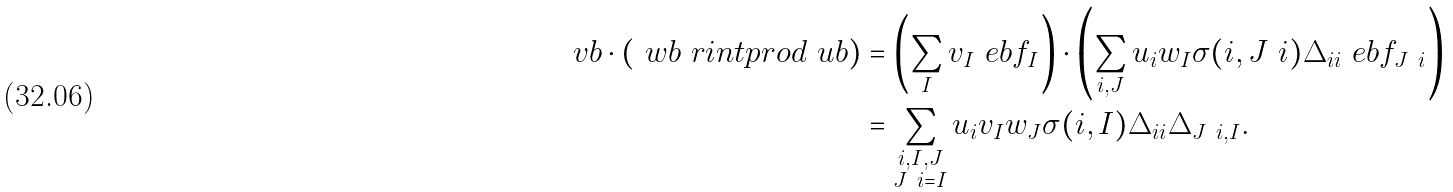Convert formula to latex. <formula><loc_0><loc_0><loc_500><loc_500>\ v b \cdot ( \ w b \ r i n t p r o d \ u b ) & = \left ( \sum _ { I } v _ { I } \ e b f _ { I } \right ) \cdot \left ( \sum _ { i , J } u _ { i } w _ { I } \sigma ( i , J \ i ) \Delta _ { i i } \ e b f _ { J \ i } \right ) \\ & = \sum _ { \substack { i , I , J \\ J \ i = I } } u _ { i } v _ { I } w _ { J } \sigma ( i , I ) \Delta _ { i i } \Delta _ { J \ i , I } .</formula> 